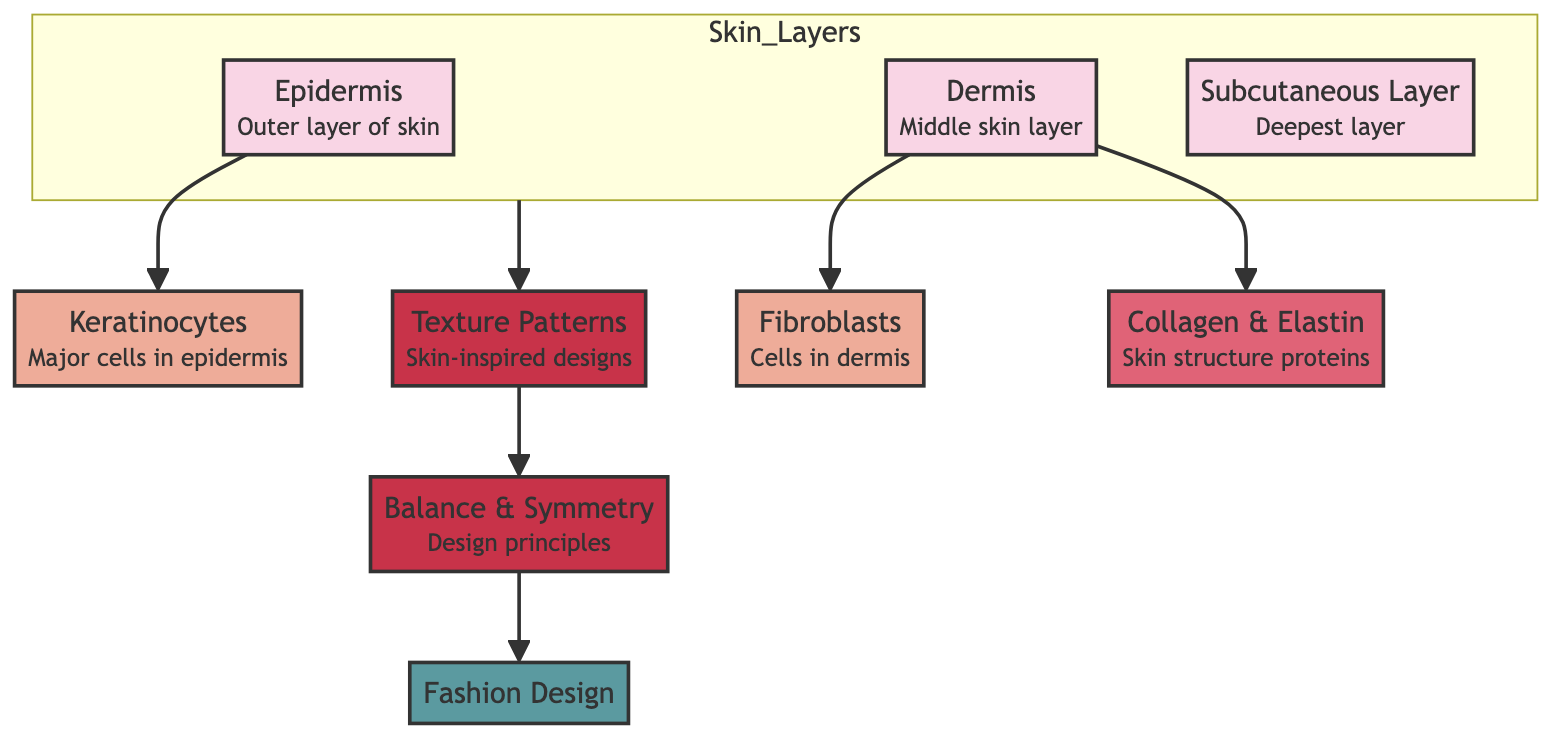What are the three layers of skin depicted in the diagram? The diagram clearly shows three layers of skin: the Epidermis, Dermis, and Subcutaneous Layer. Each layer is labeled and visually distinct.
Answer: Epidermis, Dermis, Subcutaneous Layer Which cells are primarily found in the epidermis? The diagram specifies that Keratinocytes are the major cells found in the epidermis, indicated as an arrow leading from Epidermis to Keratinocytes.
Answer: Keratinocytes How many main cell types are represented in this diagram? The diagram shows two main cell types: Keratinocytes in the Epidermis and Fibroblasts in the Dermis. Thus, counting the specific mentions provides the answer.
Answer: 2 What is the relationship between Dermis and Collagen & Elastin? The diagram indicates a direct connection from the Dermis to Collagen & Elastin, indicating that Collagen and Elastin are found within the Dermis.
Answer: Collagen & Elastin What design principle is emphasized as a result of skin-inspired texture patterns? The diagram shows a connection from Texture Patterns to Balance & Symmetry, indicating that balance and symmetry are key design principles inspired by these patterns.
Answer: Balance & Symmetry How does the flowchart indicate the transition from skin layers to fashion design? The flow starts from the Skin Layers leading to Texture Patterns, which then connects to Balance & Symmetry, finally culminating in Fashion Design, showing a clear path of inspiration.
Answer: Through Texture Patterns and Balance & Symmetry What color is used to represent the skin layers in the diagram? The skin layers are filled with a specific color defined as '#f9d5e5', making it easy to identify these components visually in the diagram.
Answer: #f9d5e5 What type of proteins does the diagram specify as skin structural components? The diagram labels the proteins in the Dermis as Collagen & Elastin, highlighting their importance in providing skin structure.
Answer: Collagen & Elastin Which subgraph contains the Epidermis? The subgraph named "Skin_Layers" includes the Epidermis along with the Dermis and Subcutaneous Layer, collectively grouped to represent the layers of skin.
Answer: Skin_Layers 